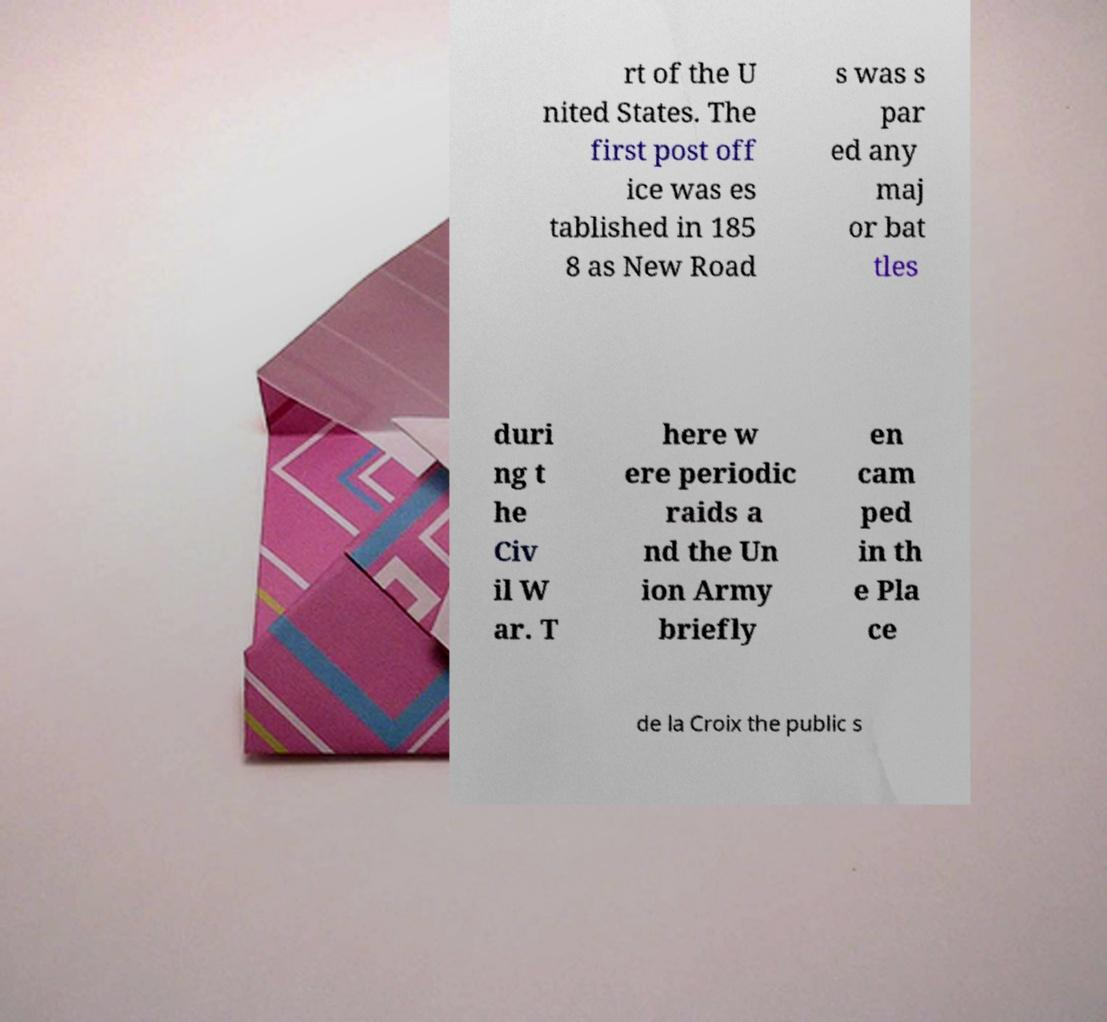Could you assist in decoding the text presented in this image and type it out clearly? rt of the U nited States. The first post off ice was es tablished in 185 8 as New Road s was s par ed any maj or bat tles duri ng t he Civ il W ar. T here w ere periodic raids a nd the Un ion Army briefly en cam ped in th e Pla ce de la Croix the public s 